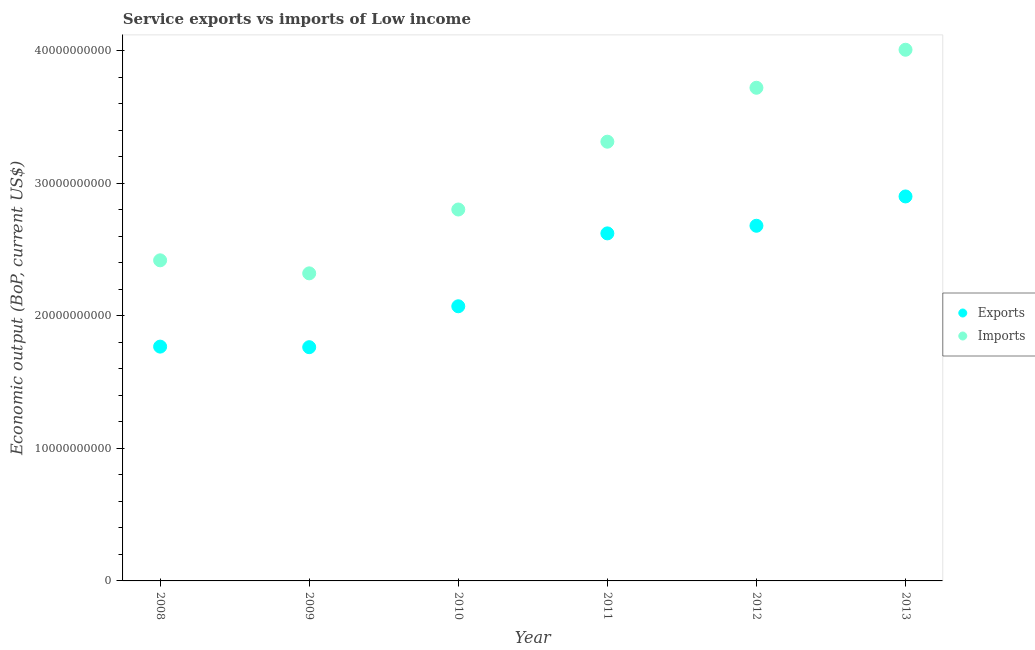How many different coloured dotlines are there?
Offer a terse response. 2. What is the amount of service imports in 2009?
Offer a terse response. 2.32e+1. Across all years, what is the maximum amount of service exports?
Offer a terse response. 2.90e+1. Across all years, what is the minimum amount of service imports?
Provide a succinct answer. 2.32e+1. In which year was the amount of service exports maximum?
Ensure brevity in your answer.  2013. What is the total amount of service exports in the graph?
Provide a succinct answer. 1.38e+11. What is the difference between the amount of service imports in 2009 and that in 2012?
Provide a short and direct response. -1.40e+1. What is the difference between the amount of service imports in 2011 and the amount of service exports in 2009?
Provide a succinct answer. 1.55e+1. What is the average amount of service imports per year?
Your response must be concise. 3.10e+1. In the year 2012, what is the difference between the amount of service imports and amount of service exports?
Make the answer very short. 1.04e+1. In how many years, is the amount of service exports greater than 34000000000 US$?
Provide a short and direct response. 0. What is the ratio of the amount of service exports in 2010 to that in 2011?
Your answer should be compact. 0.79. Is the amount of service imports in 2010 less than that in 2013?
Keep it short and to the point. Yes. Is the difference between the amount of service imports in 2009 and 2012 greater than the difference between the amount of service exports in 2009 and 2012?
Your answer should be compact. No. What is the difference between the highest and the second highest amount of service exports?
Your response must be concise. 2.21e+09. What is the difference between the highest and the lowest amount of service imports?
Provide a short and direct response. 1.69e+1. Is the amount of service imports strictly greater than the amount of service exports over the years?
Your answer should be compact. Yes. Is the amount of service imports strictly less than the amount of service exports over the years?
Ensure brevity in your answer.  No. Does the graph contain any zero values?
Make the answer very short. No. Does the graph contain grids?
Provide a short and direct response. No. Where does the legend appear in the graph?
Give a very brief answer. Center right. How are the legend labels stacked?
Give a very brief answer. Vertical. What is the title of the graph?
Ensure brevity in your answer.  Service exports vs imports of Low income. Does "GDP" appear as one of the legend labels in the graph?
Keep it short and to the point. No. What is the label or title of the Y-axis?
Your response must be concise. Economic output (BoP, current US$). What is the Economic output (BoP, current US$) of Exports in 2008?
Offer a very short reply. 1.77e+1. What is the Economic output (BoP, current US$) of Imports in 2008?
Make the answer very short. 2.42e+1. What is the Economic output (BoP, current US$) in Exports in 2009?
Offer a very short reply. 1.76e+1. What is the Economic output (BoP, current US$) of Imports in 2009?
Make the answer very short. 2.32e+1. What is the Economic output (BoP, current US$) of Exports in 2010?
Ensure brevity in your answer.  2.07e+1. What is the Economic output (BoP, current US$) of Imports in 2010?
Ensure brevity in your answer.  2.80e+1. What is the Economic output (BoP, current US$) of Exports in 2011?
Make the answer very short. 2.62e+1. What is the Economic output (BoP, current US$) of Imports in 2011?
Your answer should be compact. 3.31e+1. What is the Economic output (BoP, current US$) of Exports in 2012?
Offer a terse response. 2.68e+1. What is the Economic output (BoP, current US$) in Imports in 2012?
Provide a short and direct response. 3.72e+1. What is the Economic output (BoP, current US$) in Exports in 2013?
Ensure brevity in your answer.  2.90e+1. What is the Economic output (BoP, current US$) in Imports in 2013?
Offer a very short reply. 4.01e+1. Across all years, what is the maximum Economic output (BoP, current US$) of Exports?
Make the answer very short. 2.90e+1. Across all years, what is the maximum Economic output (BoP, current US$) in Imports?
Your answer should be compact. 4.01e+1. Across all years, what is the minimum Economic output (BoP, current US$) in Exports?
Offer a terse response. 1.76e+1. Across all years, what is the minimum Economic output (BoP, current US$) of Imports?
Make the answer very short. 2.32e+1. What is the total Economic output (BoP, current US$) of Exports in the graph?
Keep it short and to the point. 1.38e+11. What is the total Economic output (BoP, current US$) of Imports in the graph?
Your answer should be very brief. 1.86e+11. What is the difference between the Economic output (BoP, current US$) of Exports in 2008 and that in 2009?
Your response must be concise. 4.28e+07. What is the difference between the Economic output (BoP, current US$) of Imports in 2008 and that in 2009?
Your answer should be compact. 9.83e+08. What is the difference between the Economic output (BoP, current US$) in Exports in 2008 and that in 2010?
Provide a succinct answer. -3.04e+09. What is the difference between the Economic output (BoP, current US$) in Imports in 2008 and that in 2010?
Offer a very short reply. -3.83e+09. What is the difference between the Economic output (BoP, current US$) in Exports in 2008 and that in 2011?
Provide a short and direct response. -8.54e+09. What is the difference between the Economic output (BoP, current US$) in Imports in 2008 and that in 2011?
Make the answer very short. -8.95e+09. What is the difference between the Economic output (BoP, current US$) in Exports in 2008 and that in 2012?
Ensure brevity in your answer.  -9.12e+09. What is the difference between the Economic output (BoP, current US$) of Imports in 2008 and that in 2012?
Your answer should be very brief. -1.30e+1. What is the difference between the Economic output (BoP, current US$) of Exports in 2008 and that in 2013?
Make the answer very short. -1.13e+1. What is the difference between the Economic output (BoP, current US$) of Imports in 2008 and that in 2013?
Your response must be concise. -1.59e+1. What is the difference between the Economic output (BoP, current US$) in Exports in 2009 and that in 2010?
Offer a very short reply. -3.09e+09. What is the difference between the Economic output (BoP, current US$) in Imports in 2009 and that in 2010?
Make the answer very short. -4.82e+09. What is the difference between the Economic output (BoP, current US$) in Exports in 2009 and that in 2011?
Offer a terse response. -8.59e+09. What is the difference between the Economic output (BoP, current US$) in Imports in 2009 and that in 2011?
Keep it short and to the point. -9.93e+09. What is the difference between the Economic output (BoP, current US$) in Exports in 2009 and that in 2012?
Provide a succinct answer. -9.16e+09. What is the difference between the Economic output (BoP, current US$) of Imports in 2009 and that in 2012?
Give a very brief answer. -1.40e+1. What is the difference between the Economic output (BoP, current US$) of Exports in 2009 and that in 2013?
Make the answer very short. -1.14e+1. What is the difference between the Economic output (BoP, current US$) of Imports in 2009 and that in 2013?
Offer a very short reply. -1.69e+1. What is the difference between the Economic output (BoP, current US$) in Exports in 2010 and that in 2011?
Provide a succinct answer. -5.50e+09. What is the difference between the Economic output (BoP, current US$) in Imports in 2010 and that in 2011?
Keep it short and to the point. -5.12e+09. What is the difference between the Economic output (BoP, current US$) of Exports in 2010 and that in 2012?
Your answer should be compact. -6.07e+09. What is the difference between the Economic output (BoP, current US$) of Imports in 2010 and that in 2012?
Give a very brief answer. -9.19e+09. What is the difference between the Economic output (BoP, current US$) in Exports in 2010 and that in 2013?
Your answer should be compact. -8.29e+09. What is the difference between the Economic output (BoP, current US$) of Imports in 2010 and that in 2013?
Your response must be concise. -1.21e+1. What is the difference between the Economic output (BoP, current US$) of Exports in 2011 and that in 2012?
Your answer should be compact. -5.75e+08. What is the difference between the Economic output (BoP, current US$) in Imports in 2011 and that in 2012?
Your response must be concise. -4.07e+09. What is the difference between the Economic output (BoP, current US$) in Exports in 2011 and that in 2013?
Ensure brevity in your answer.  -2.79e+09. What is the difference between the Economic output (BoP, current US$) in Imports in 2011 and that in 2013?
Provide a succinct answer. -6.94e+09. What is the difference between the Economic output (BoP, current US$) in Exports in 2012 and that in 2013?
Provide a succinct answer. -2.21e+09. What is the difference between the Economic output (BoP, current US$) of Imports in 2012 and that in 2013?
Keep it short and to the point. -2.87e+09. What is the difference between the Economic output (BoP, current US$) of Exports in 2008 and the Economic output (BoP, current US$) of Imports in 2009?
Ensure brevity in your answer.  -5.53e+09. What is the difference between the Economic output (BoP, current US$) in Exports in 2008 and the Economic output (BoP, current US$) in Imports in 2010?
Your response must be concise. -1.03e+1. What is the difference between the Economic output (BoP, current US$) of Exports in 2008 and the Economic output (BoP, current US$) of Imports in 2011?
Keep it short and to the point. -1.55e+1. What is the difference between the Economic output (BoP, current US$) of Exports in 2008 and the Economic output (BoP, current US$) of Imports in 2012?
Ensure brevity in your answer.  -1.95e+1. What is the difference between the Economic output (BoP, current US$) of Exports in 2008 and the Economic output (BoP, current US$) of Imports in 2013?
Provide a succinct answer. -2.24e+1. What is the difference between the Economic output (BoP, current US$) in Exports in 2009 and the Economic output (BoP, current US$) in Imports in 2010?
Provide a short and direct response. -1.04e+1. What is the difference between the Economic output (BoP, current US$) in Exports in 2009 and the Economic output (BoP, current US$) in Imports in 2011?
Your response must be concise. -1.55e+1. What is the difference between the Economic output (BoP, current US$) in Exports in 2009 and the Economic output (BoP, current US$) in Imports in 2012?
Keep it short and to the point. -1.96e+1. What is the difference between the Economic output (BoP, current US$) in Exports in 2009 and the Economic output (BoP, current US$) in Imports in 2013?
Ensure brevity in your answer.  -2.24e+1. What is the difference between the Economic output (BoP, current US$) of Exports in 2010 and the Economic output (BoP, current US$) of Imports in 2011?
Make the answer very short. -1.24e+1. What is the difference between the Economic output (BoP, current US$) of Exports in 2010 and the Economic output (BoP, current US$) of Imports in 2012?
Provide a short and direct response. -1.65e+1. What is the difference between the Economic output (BoP, current US$) in Exports in 2010 and the Economic output (BoP, current US$) in Imports in 2013?
Ensure brevity in your answer.  -1.94e+1. What is the difference between the Economic output (BoP, current US$) of Exports in 2011 and the Economic output (BoP, current US$) of Imports in 2012?
Provide a succinct answer. -1.10e+1. What is the difference between the Economic output (BoP, current US$) in Exports in 2011 and the Economic output (BoP, current US$) in Imports in 2013?
Your answer should be compact. -1.39e+1. What is the difference between the Economic output (BoP, current US$) in Exports in 2012 and the Economic output (BoP, current US$) in Imports in 2013?
Your answer should be very brief. -1.33e+1. What is the average Economic output (BoP, current US$) of Exports per year?
Make the answer very short. 2.30e+1. What is the average Economic output (BoP, current US$) in Imports per year?
Keep it short and to the point. 3.10e+1. In the year 2008, what is the difference between the Economic output (BoP, current US$) of Exports and Economic output (BoP, current US$) of Imports?
Your answer should be very brief. -6.51e+09. In the year 2009, what is the difference between the Economic output (BoP, current US$) in Exports and Economic output (BoP, current US$) in Imports?
Provide a short and direct response. -5.57e+09. In the year 2010, what is the difference between the Economic output (BoP, current US$) in Exports and Economic output (BoP, current US$) in Imports?
Make the answer very short. -7.30e+09. In the year 2011, what is the difference between the Economic output (BoP, current US$) of Exports and Economic output (BoP, current US$) of Imports?
Ensure brevity in your answer.  -6.92e+09. In the year 2012, what is the difference between the Economic output (BoP, current US$) of Exports and Economic output (BoP, current US$) of Imports?
Provide a succinct answer. -1.04e+1. In the year 2013, what is the difference between the Economic output (BoP, current US$) in Exports and Economic output (BoP, current US$) in Imports?
Your response must be concise. -1.11e+1. What is the ratio of the Economic output (BoP, current US$) in Imports in 2008 to that in 2009?
Give a very brief answer. 1.04. What is the ratio of the Economic output (BoP, current US$) in Exports in 2008 to that in 2010?
Offer a terse response. 0.85. What is the ratio of the Economic output (BoP, current US$) of Imports in 2008 to that in 2010?
Your response must be concise. 0.86. What is the ratio of the Economic output (BoP, current US$) in Exports in 2008 to that in 2011?
Ensure brevity in your answer.  0.67. What is the ratio of the Economic output (BoP, current US$) in Imports in 2008 to that in 2011?
Offer a terse response. 0.73. What is the ratio of the Economic output (BoP, current US$) in Exports in 2008 to that in 2012?
Your answer should be compact. 0.66. What is the ratio of the Economic output (BoP, current US$) of Imports in 2008 to that in 2012?
Keep it short and to the point. 0.65. What is the ratio of the Economic output (BoP, current US$) of Exports in 2008 to that in 2013?
Your response must be concise. 0.61. What is the ratio of the Economic output (BoP, current US$) of Imports in 2008 to that in 2013?
Make the answer very short. 0.6. What is the ratio of the Economic output (BoP, current US$) in Exports in 2009 to that in 2010?
Ensure brevity in your answer.  0.85. What is the ratio of the Economic output (BoP, current US$) in Imports in 2009 to that in 2010?
Ensure brevity in your answer.  0.83. What is the ratio of the Economic output (BoP, current US$) of Exports in 2009 to that in 2011?
Your answer should be compact. 0.67. What is the ratio of the Economic output (BoP, current US$) in Imports in 2009 to that in 2011?
Ensure brevity in your answer.  0.7. What is the ratio of the Economic output (BoP, current US$) of Exports in 2009 to that in 2012?
Offer a very short reply. 0.66. What is the ratio of the Economic output (BoP, current US$) of Imports in 2009 to that in 2012?
Provide a short and direct response. 0.62. What is the ratio of the Economic output (BoP, current US$) in Exports in 2009 to that in 2013?
Your response must be concise. 0.61. What is the ratio of the Economic output (BoP, current US$) in Imports in 2009 to that in 2013?
Give a very brief answer. 0.58. What is the ratio of the Economic output (BoP, current US$) in Exports in 2010 to that in 2011?
Provide a short and direct response. 0.79. What is the ratio of the Economic output (BoP, current US$) of Imports in 2010 to that in 2011?
Your answer should be compact. 0.85. What is the ratio of the Economic output (BoP, current US$) in Exports in 2010 to that in 2012?
Give a very brief answer. 0.77. What is the ratio of the Economic output (BoP, current US$) of Imports in 2010 to that in 2012?
Offer a terse response. 0.75. What is the ratio of the Economic output (BoP, current US$) of Imports in 2010 to that in 2013?
Your answer should be compact. 0.7. What is the ratio of the Economic output (BoP, current US$) of Exports in 2011 to that in 2012?
Your response must be concise. 0.98. What is the ratio of the Economic output (BoP, current US$) in Imports in 2011 to that in 2012?
Give a very brief answer. 0.89. What is the ratio of the Economic output (BoP, current US$) of Exports in 2011 to that in 2013?
Make the answer very short. 0.9. What is the ratio of the Economic output (BoP, current US$) of Imports in 2011 to that in 2013?
Make the answer very short. 0.83. What is the ratio of the Economic output (BoP, current US$) in Exports in 2012 to that in 2013?
Ensure brevity in your answer.  0.92. What is the ratio of the Economic output (BoP, current US$) of Imports in 2012 to that in 2013?
Ensure brevity in your answer.  0.93. What is the difference between the highest and the second highest Economic output (BoP, current US$) of Exports?
Give a very brief answer. 2.21e+09. What is the difference between the highest and the second highest Economic output (BoP, current US$) of Imports?
Your response must be concise. 2.87e+09. What is the difference between the highest and the lowest Economic output (BoP, current US$) in Exports?
Provide a short and direct response. 1.14e+1. What is the difference between the highest and the lowest Economic output (BoP, current US$) of Imports?
Your answer should be very brief. 1.69e+1. 